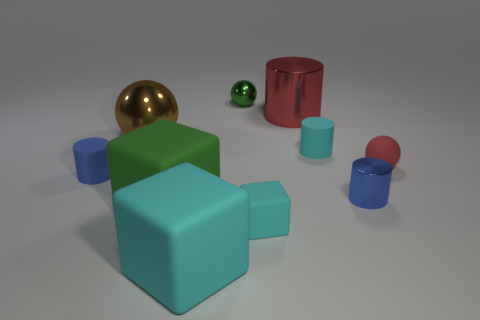How many objects in the image have a reflective surface? There are three objects in the image that exhibit a reflective surface: the golden ball, the green sphere, and the crimson cylinder. What does their reflectiveness suggest about the material they might be made from? The reflective quality of their surfaces suggests that these objects may be made from materials like polished metal or glossy plastic, materials that are capable of producing clear reflections and highlights. 